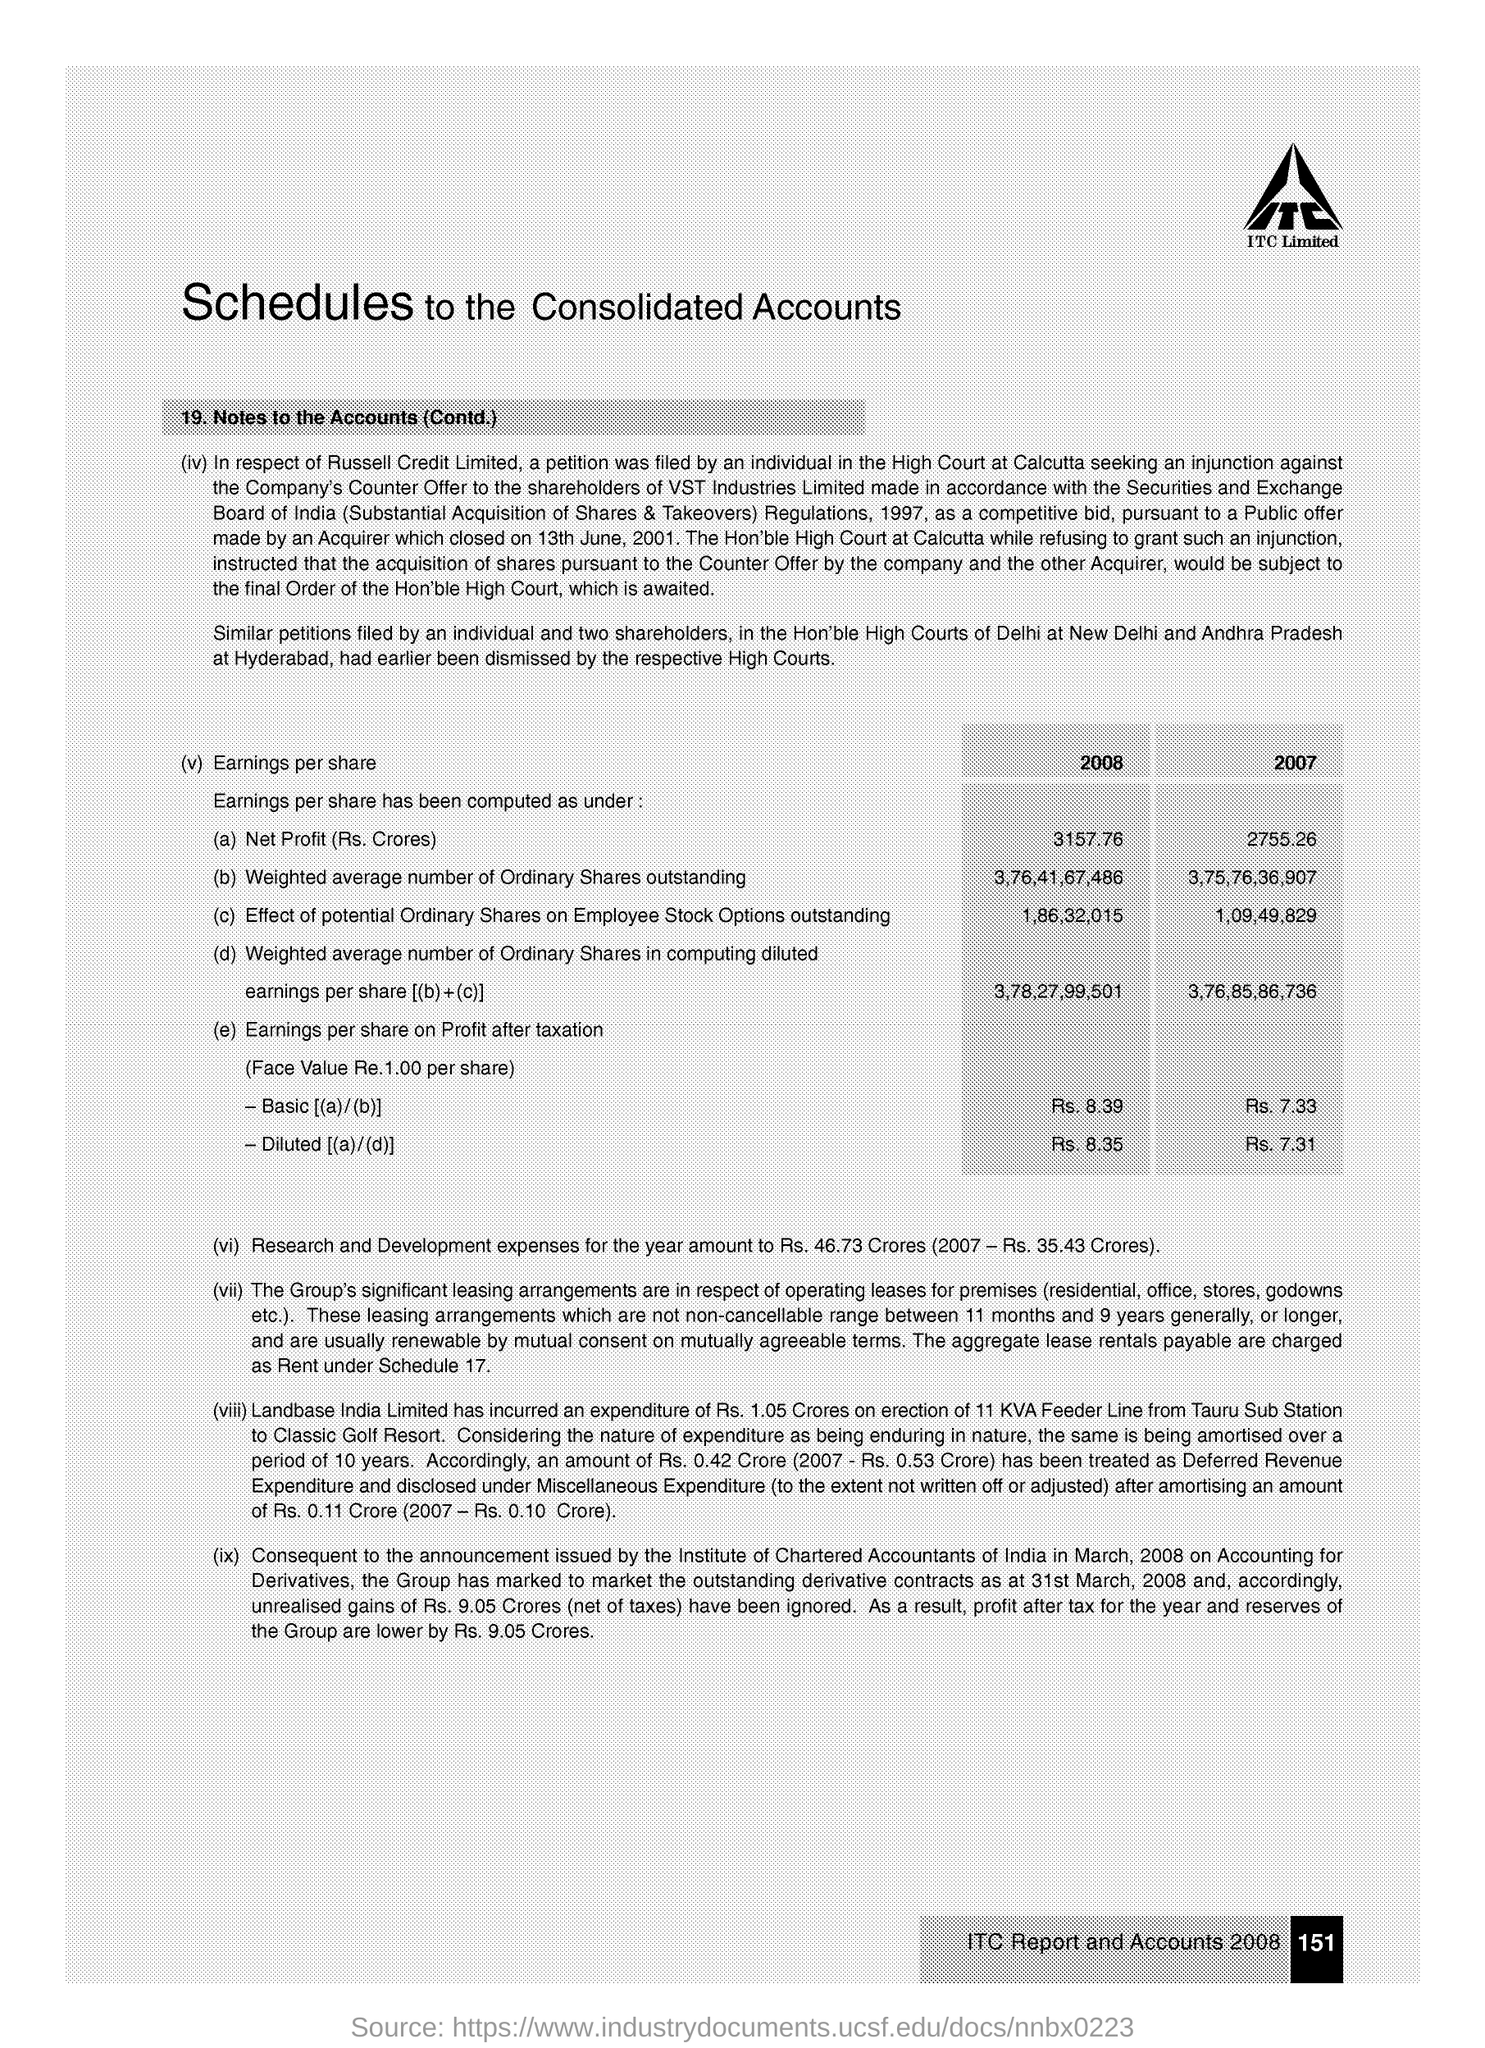Indicate a few pertinent items in this graphic. The research and development expenses for the year were Rs. 46.73 crores, which is an increase from the previous year's expenses of Rs. 35.43 crores. The net profit in the year 2008 was Rs. 3157.76 crores. 